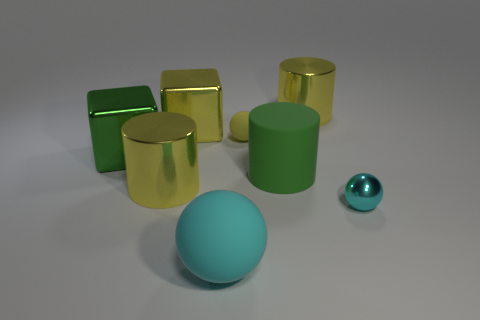Add 1 small objects. How many objects exist? 9 Subtract all blocks. How many objects are left? 6 Add 4 large balls. How many large balls are left? 5 Add 8 metal cubes. How many metal cubes exist? 10 Subtract 0 blue cylinders. How many objects are left? 8 Subtract all brown cylinders. Subtract all big things. How many objects are left? 2 